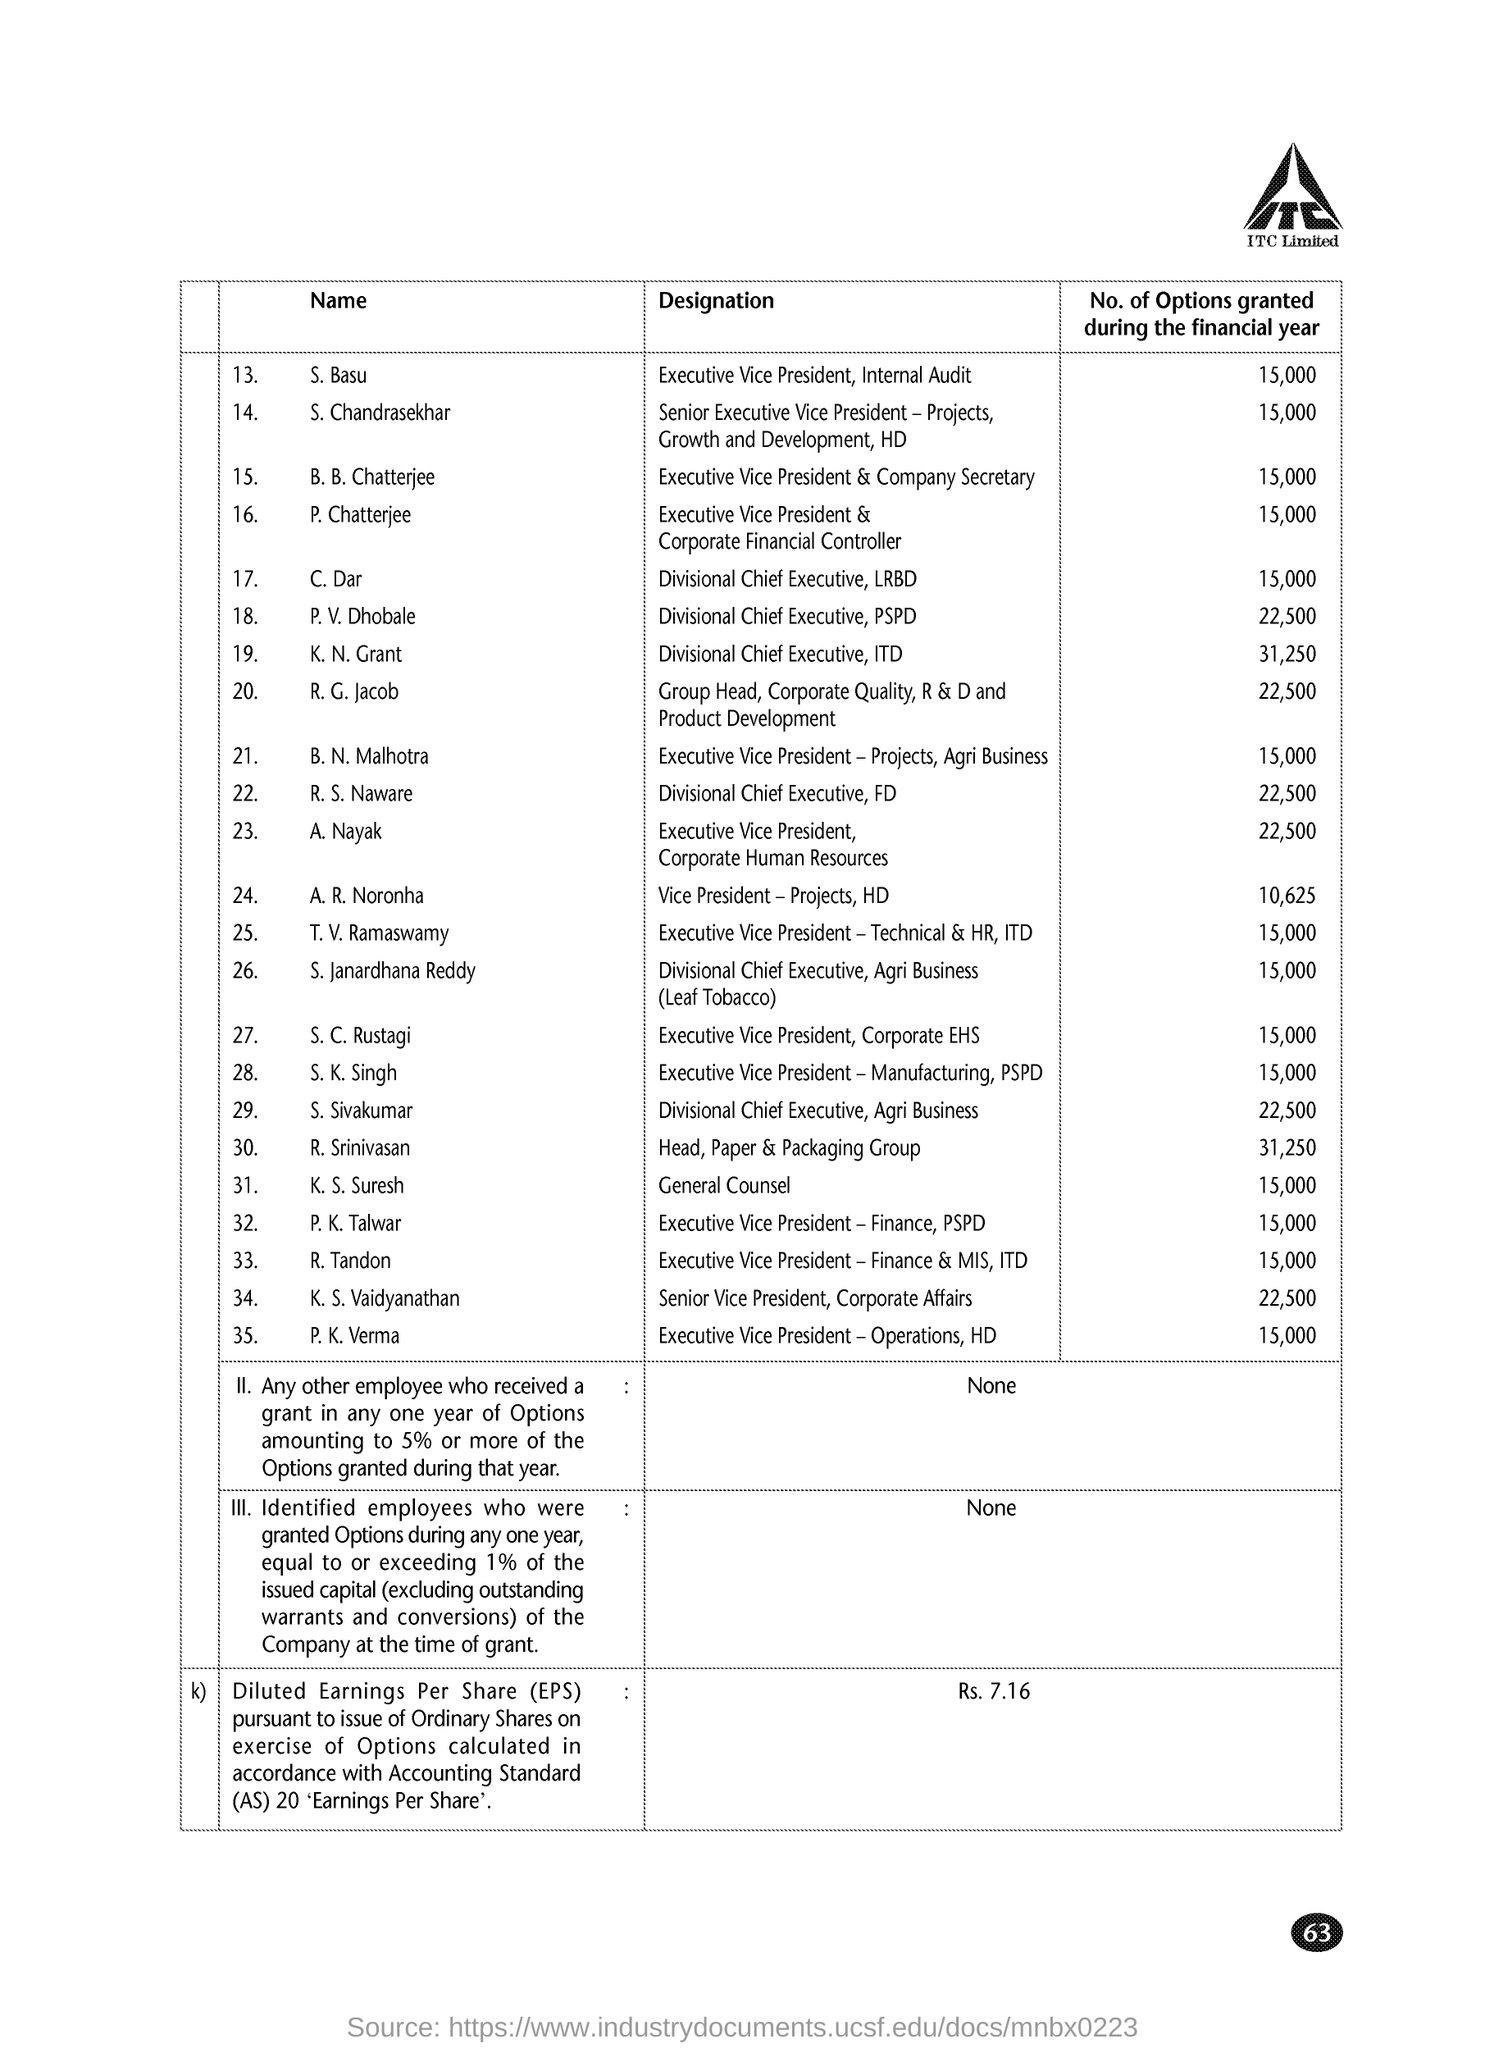Who is the executive vice president & company secretary ?
Provide a short and direct response. B.B. Chatterjee. How many no of options are granted during the financial year for c.dar ?
Your response must be concise. 15,000. What is the designation of r.s.naware?
Offer a very short reply. Divisional chief executive,fd. How many no of options are granted during the financial year for s.chandrasekhar?
Make the answer very short. 15,000. What is the designation of k.s.suresh ?
Give a very brief answer. General Counsel. Who is the senior vice president ,of corporate affairs ?
Offer a very short reply. K.S. Vaidyanathan. 